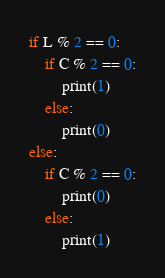<code> <loc_0><loc_0><loc_500><loc_500><_Python_>if L % 2 == 0:
    if C % 2 == 0:
        print(1)
    else:
        print(0)
else:
    if C % 2 == 0:
        print(0)
    else:
        print(1)</code> 